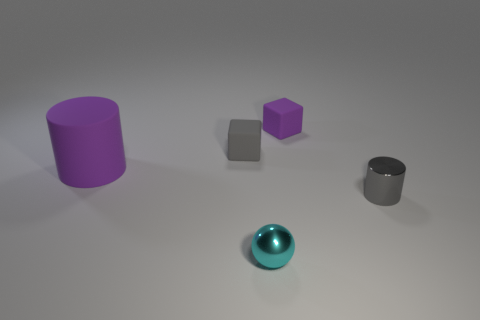Can you tell me what the function of these objects might be if they were real? If these objects were real, they might serve various functions. The cylinders could be containers or parts of machinery, the cubes could be building blocks or weights, and the sphere could be a decorative item or a part of a larger assembly. 